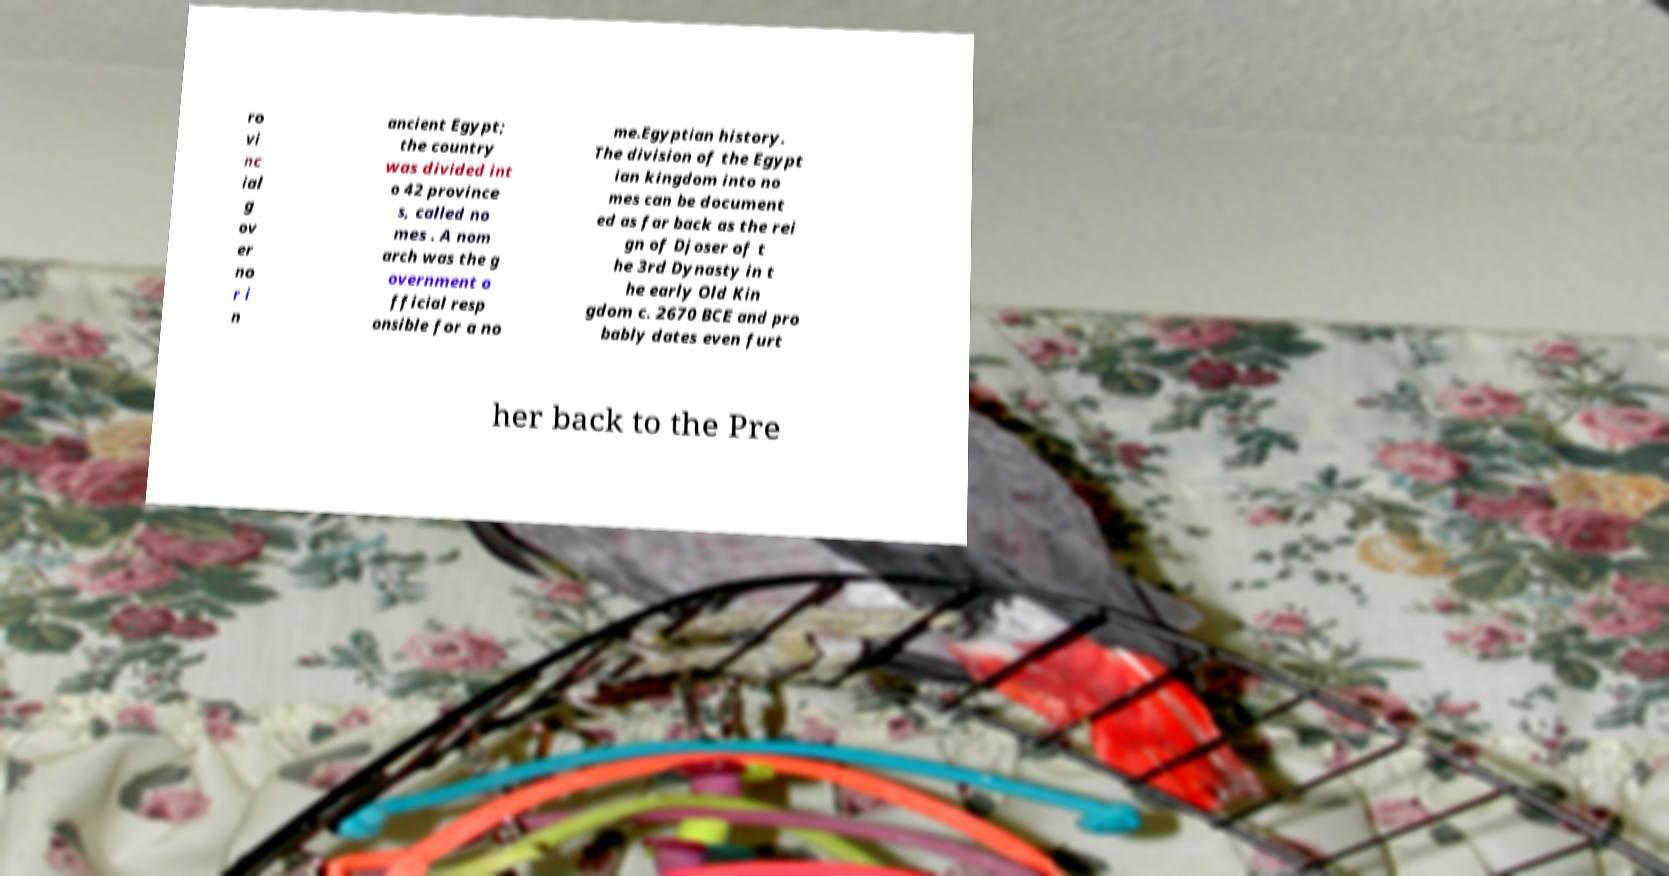For documentation purposes, I need the text within this image transcribed. Could you provide that? ro vi nc ial g ov er no r i n ancient Egypt; the country was divided int o 42 province s, called no mes . A nom arch was the g overnment o fficial resp onsible for a no me.Egyptian history. The division of the Egypt ian kingdom into no mes can be document ed as far back as the rei gn of Djoser of t he 3rd Dynasty in t he early Old Kin gdom c. 2670 BCE and pro bably dates even furt her back to the Pre 